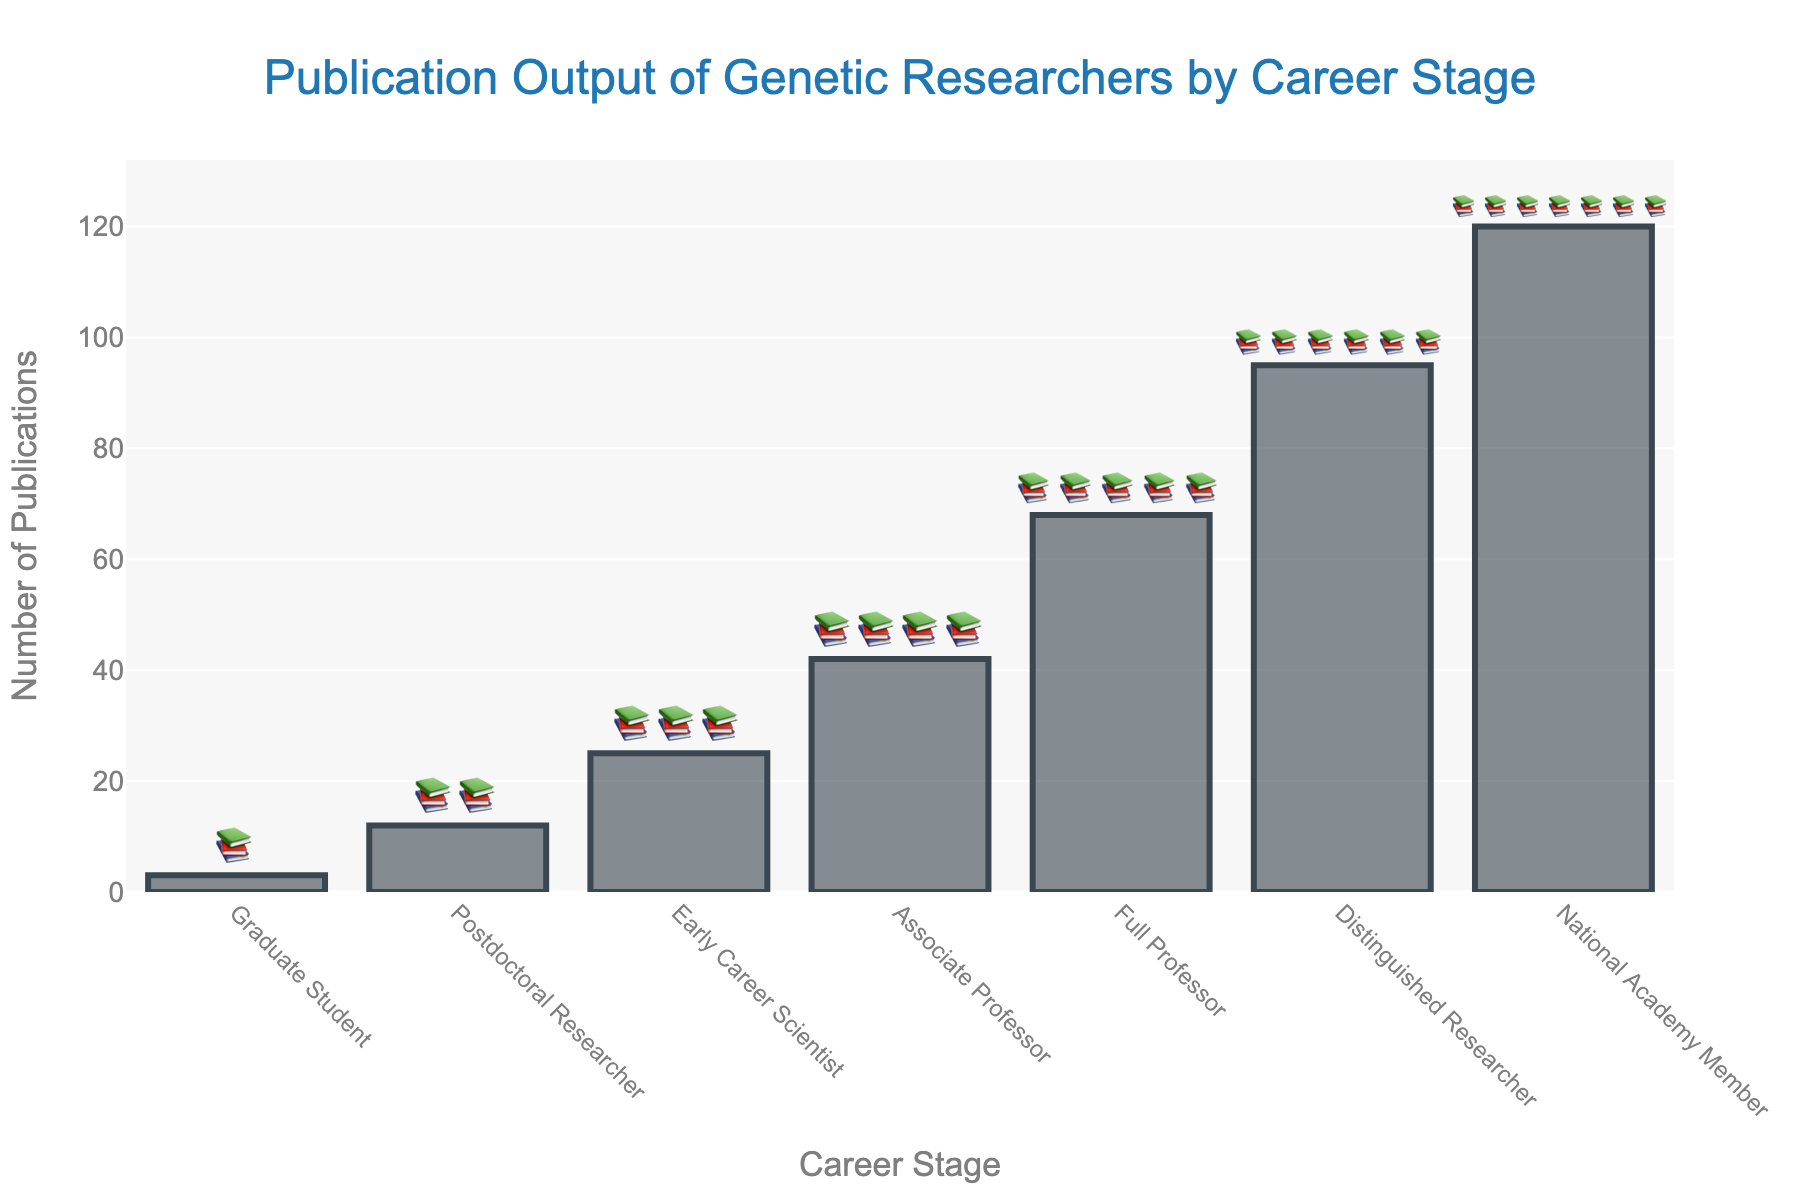What's the title of the chart? The title is located at the top of the chart and it provides a summary of what the chart is about.
Answer: Publication Output of Genetic Researchers by Career Stage How many career stages are presented in the chart? The number of different career stages can be found by counting the distinct categories on the x-axis.
Answer: Seven Which career stage has the highest number of publications? Find the tallest bar in the chart and identify its corresponding career stage from the x-axis.
Answer: National Academy Member How many publications do Graduate Students have? Locate the bar corresponding to Graduate Students on the x-axis and read the value from the y-axis.
Answer: 3 What's the difference in publications between a Postdoctoral Researcher and an Associate Professor? Find the number of publications for both careers from the chart and subtract one from the other (42 - 12).
Answer: 30 What is the sum of publications for Early Career Scientists and Full Professors? Find the number of publications for both careers and add them together (25 + 68).
Answer: 93 Which career stage has more publications: Early Career Scientist or Associate Professor? Compare the publication values of Early Career Scientists and Associate Professors by identifying which bar is taller.
Answer: Associate Professor What is the average number of publications for the first three career stages? Calculate by adding the number of publications for Graduate Students, Postdoctoral Researchers, and Early Career Scientists, then divide by 3 ((3 + 12 + 25) / 3).
Answer: 13.33 How does the number of publications for a Distinguished Researcher compare to a National Academy Member? Observe the heights of the bars for Distinguished Researcher and National Academy Member, noting the numerical difference (120 - 95).
Answer: National Academy Member has 25 more publications How many book emojis are shown for Full Professors? Identify the text corresponding to Full Professor and count the number of book emojis.
Answer: 5 